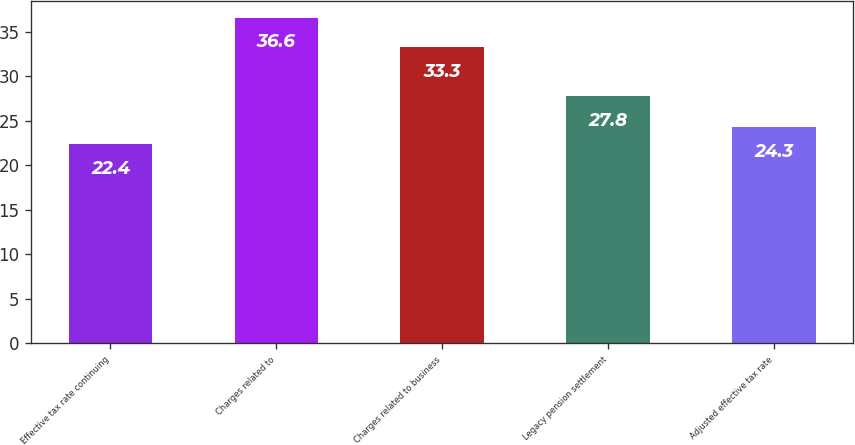Convert chart. <chart><loc_0><loc_0><loc_500><loc_500><bar_chart><fcel>Effective tax rate continuing<fcel>Charges related to<fcel>Charges related to business<fcel>Legacy pension settlement<fcel>Adjusted effective tax rate<nl><fcel>22.4<fcel>36.6<fcel>33.3<fcel>27.8<fcel>24.3<nl></chart> 